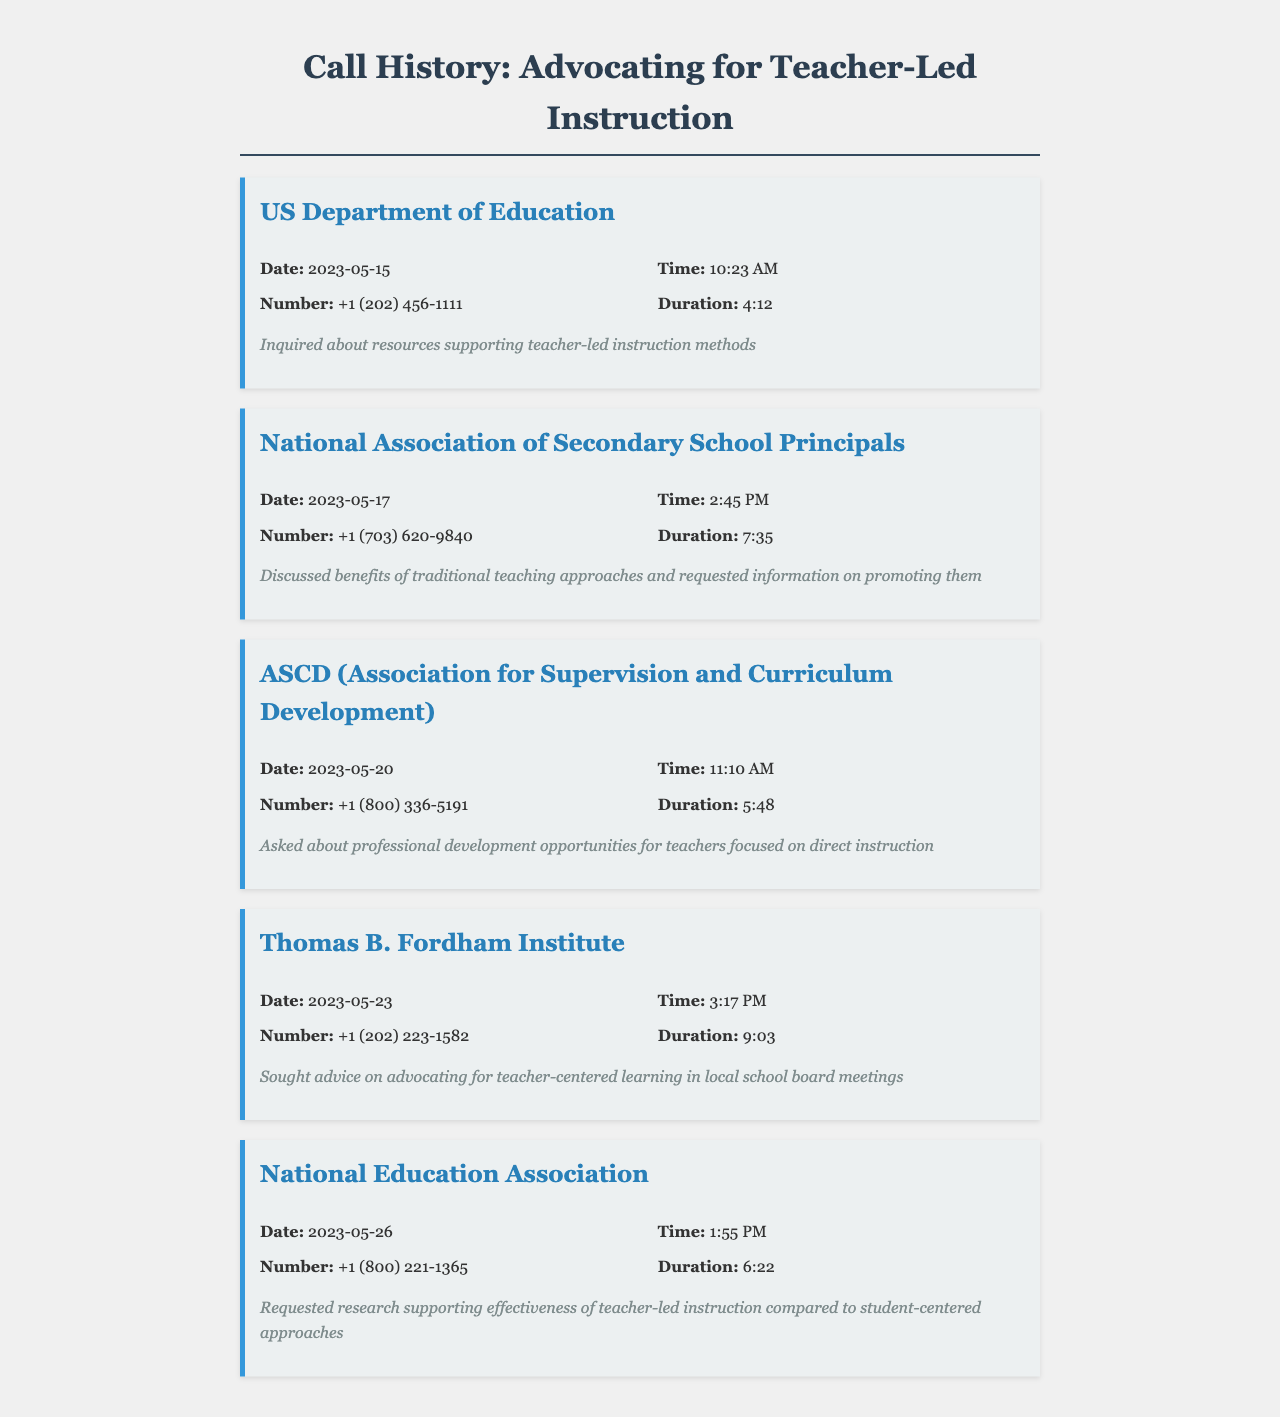what is the date of the call to the US Department of Education? The date of the call is mentioned in the call record as May 15, 2023.
Answer: May 15, 2023 what was the duration of the call with the National Association of Secondary School Principals? The duration of the call is given in the call record as 7 minutes and 35 seconds.
Answer: 7:35 who did the parent speak with on May 20, 2023? The organization contacted on this date is ASCD (Association for Supervision and Curriculum Development).
Answer: ASCD what specific information was requested from the National Education Association? The call record shows that research supporting the effectiveness of teacher-led instruction was requested.
Answer: Research supporting effectiveness how many calls were made in total? The document lists a total of five distinct call records.
Answer: 5 what was discussed during the call with the Thomas B. Fordham Institute? The notes indicate that advice on advocating for teacher-centered learning in local school board meetings was sought.
Answer: Advocating for teacher-centered learning what time did the call to the National Education Association occur? The time of the call is documented as 1:55 PM.
Answer: 1:55 PM which organization was contacted to inquire about professional development opportunities for teachers? The call record indicates that ASCD was contacted for this purpose.
Answer: ASCD 